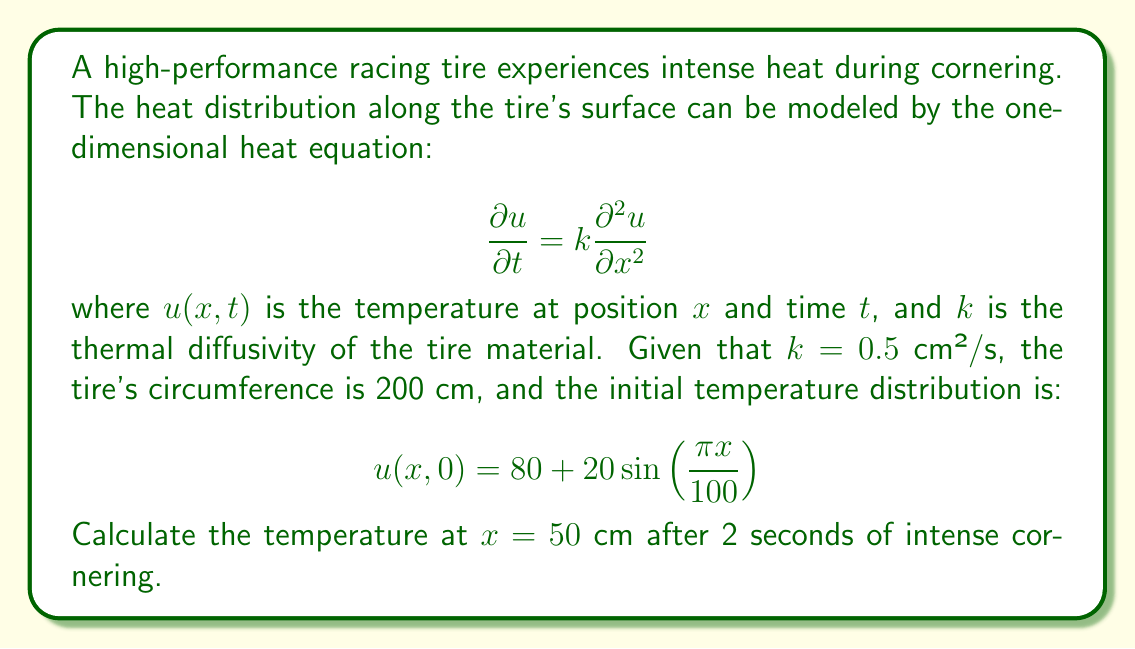Can you solve this math problem? To solve this problem, we'll use the method of separation of variables:

1) Assume a solution of the form $u(x,t) = X(x)T(t)$

2) Substituting into the heat equation:
   $$X(x)T'(t) = kX''(x)T(t)$$
   $$\frac{T'(t)}{kT(t)} = \frac{X''(x)}{X(x)} = -\lambda$$

3) This gives us two ODEs:
   $$T'(t) + k\lambda T(t) = 0$$
   $$X''(x) + \lambda X(x) = 0$$

4) The general solutions are:
   $$T(t) = Ae^{-k\lambda t}$$
   $$X(x) = B\sin(\sqrt{\lambda}x) + C\cos(\sqrt{\lambda}x)$$

5) Given the periodic nature of the tire and the initial condition, we can deduce:
   $$\lambda_n = \left(\frac{n\pi}{100}\right)^2, n = 0, 1, 2, ...$$

6) The complete solution is:
   $$u(x,t) = \sum_{n=0}^{\infty} \left(A_n\sin\left(\frac{n\pi x}{100}\right) + B_n\cos\left(\frac{n\pi x}{100}\right)\right)e^{-k\left(\frac{n\pi}{100}\right)^2t}$$

7) Applying the initial condition:
   $$u(x,0) = 80 + 20\sin\left(\frac{\pi x}{100}\right)$$

8) We can see that $B_0 = 80$, $A_1 = 20$, and all other coefficients are zero.

9) Therefore, the solution is:
   $$u(x,t) = 80 + 20\sin\left(\frac{\pi x}{100}\right)e^{-k\left(\frac{\pi}{100}\right)^2t}$$

10) At $x = 50$ cm and $t = 2$ s, with $k = 0.5$ cm²/s:
    $$u(50,2) = 80 + 20\sin\left(\frac{\pi 50}{100}\right)e^{-0.5\left(\frac{\pi}{100}\right)^2 2}$$
    $$= 80 + 20 \cdot 1 \cdot e^{-0.000493}$$
    $$\approx 99.98°C$$
Answer: 99.98°C 